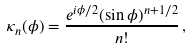Convert formula to latex. <formula><loc_0><loc_0><loc_500><loc_500>\kappa _ { n } ( \phi ) = \frac { e ^ { i \phi / 2 } ( \sin \phi ) ^ { n + 1 / 2 } } { n ! } \, ,</formula> 